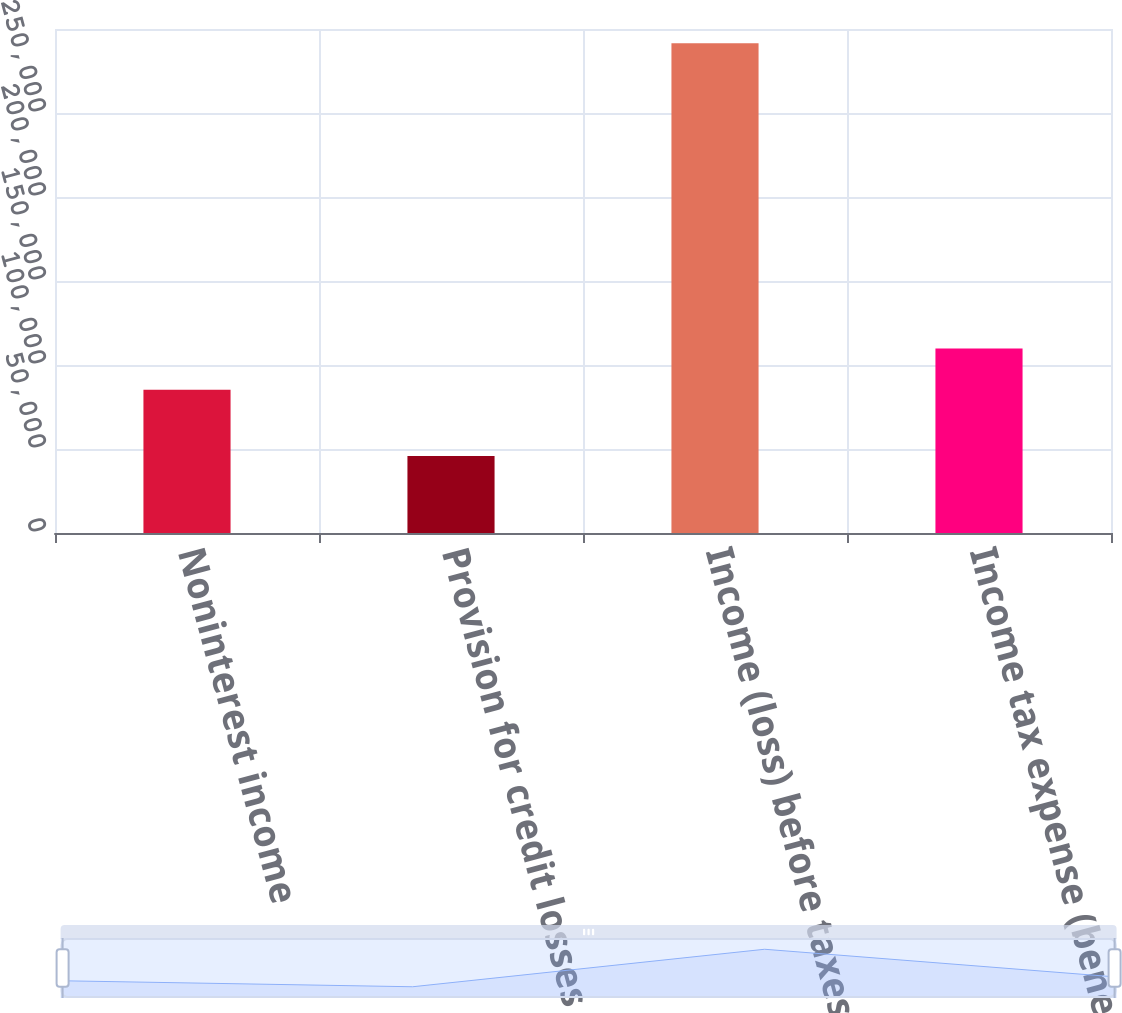Convert chart to OTSL. <chart><loc_0><loc_0><loc_500><loc_500><bar_chart><fcel>Noninterest income<fcel>Provision for credit losses<fcel>Income (loss) before taxes<fcel>Income tax expense (benefit)<nl><fcel>85200<fcel>45781<fcel>291553<fcel>109777<nl></chart> 